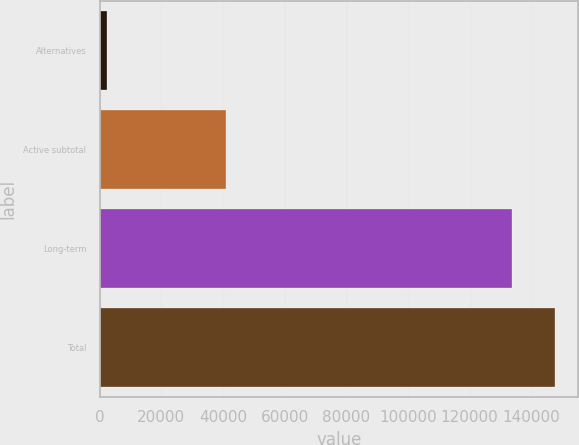Convert chart. <chart><loc_0><loc_0><loc_500><loc_500><bar_chart><fcel>Alternatives<fcel>Active subtotal<fcel>Long-term<fcel>Total<nl><fcel>2479<fcel>40974<fcel>133874<fcel>147718<nl></chart> 